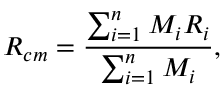<formula> <loc_0><loc_0><loc_500><loc_500>R _ { c m } = \frac { \sum _ { i = 1 } ^ { n } M _ { i } R _ { i } } { \sum _ { i = 1 } ^ { n } M _ { i } } ,</formula> 